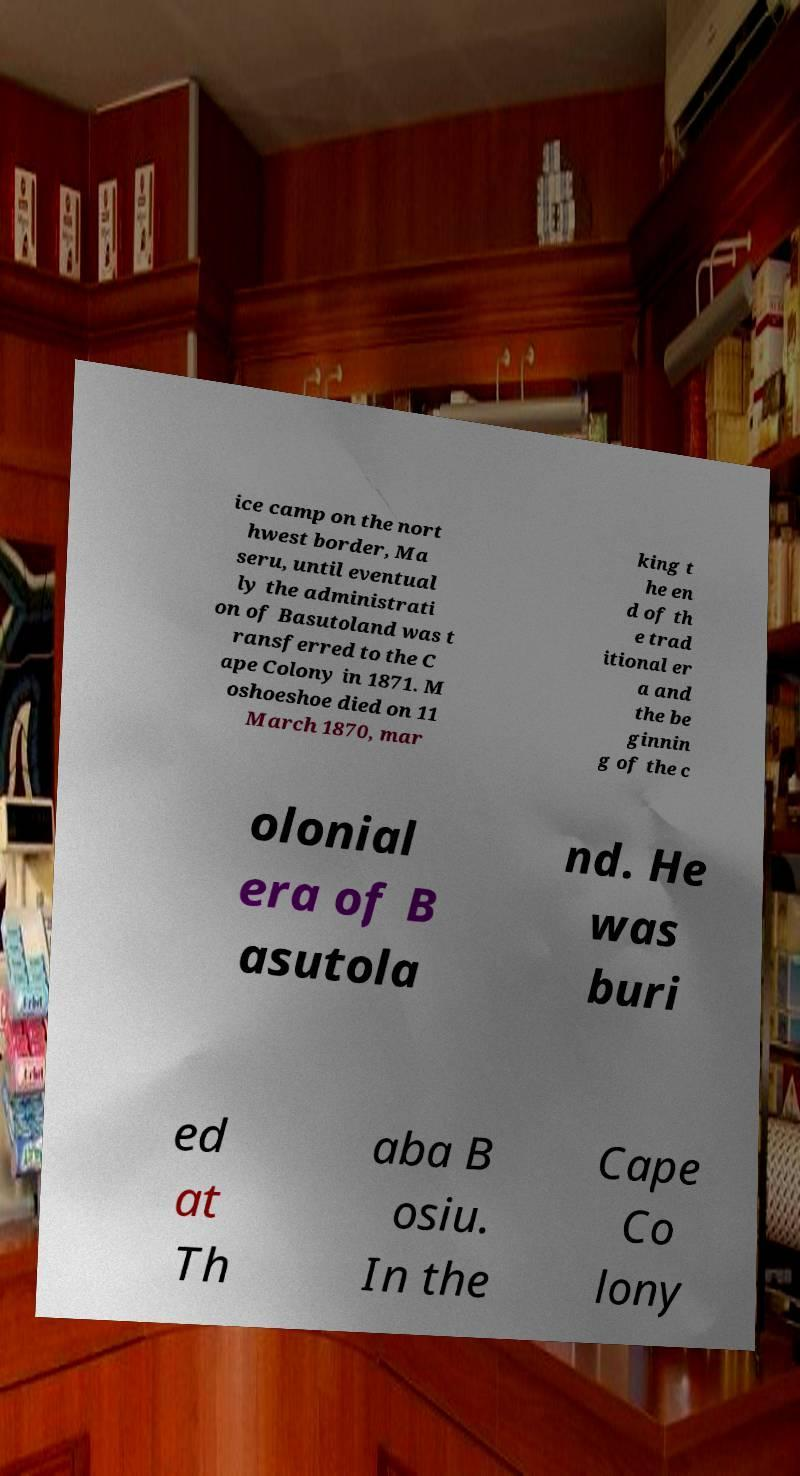Could you assist in decoding the text presented in this image and type it out clearly? ice camp on the nort hwest border, Ma seru, until eventual ly the administrati on of Basutoland was t ransferred to the C ape Colony in 1871. M oshoeshoe died on 11 March 1870, mar king t he en d of th e trad itional er a and the be ginnin g of the c olonial era of B asutola nd. He was buri ed at Th aba B osiu. In the Cape Co lony 